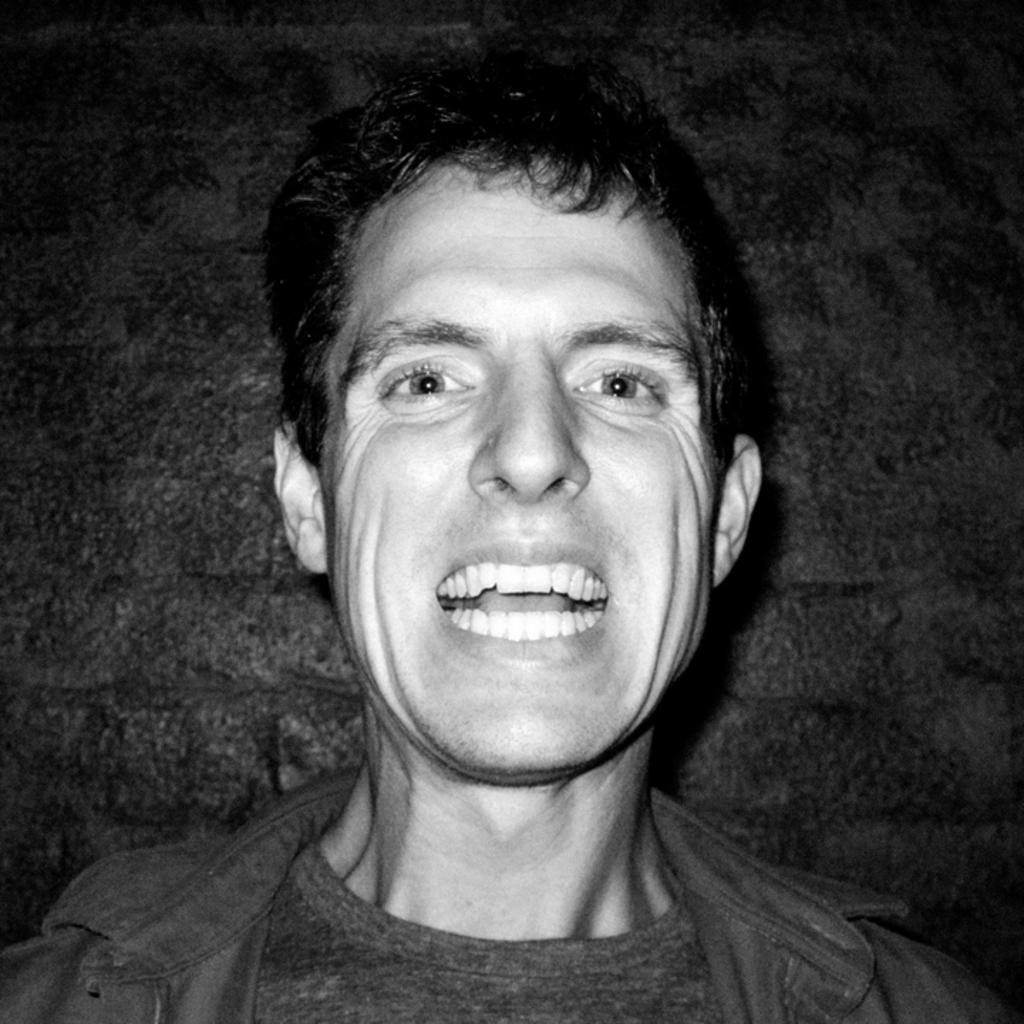What is the color scheme of the image? The image is black and white. Who is present in the image? There is a man in the image. What is the man doing in the image? The man is smiling in the image. What can be seen behind the man? There is a wall behind the man. What type of carriage is being pulled by the horses in the image? There are no horses or carriages present in the image; it features a man smiling in front of a wall. How many divisions can be seen in the image? There are no divisions or sections present in the image; it is a simple scene of a man smiling in front of a wall. 